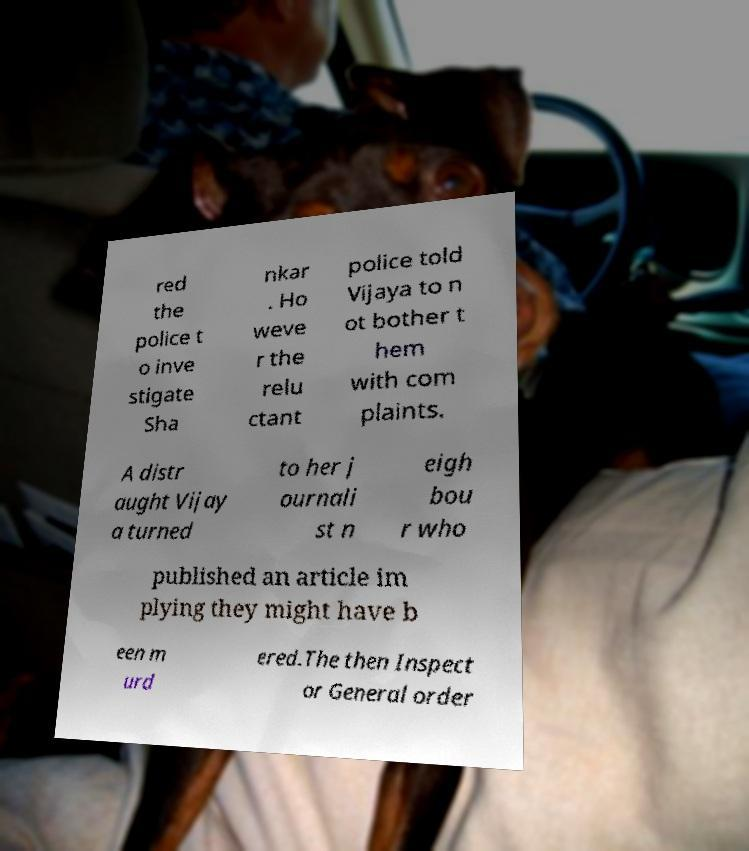Could you assist in decoding the text presented in this image and type it out clearly? red the police t o inve stigate Sha nkar . Ho weve r the relu ctant police told Vijaya to n ot bother t hem with com plaints. A distr aught Vijay a turned to her j ournali st n eigh bou r who published an article im plying they might have b een m urd ered.The then Inspect or General order 